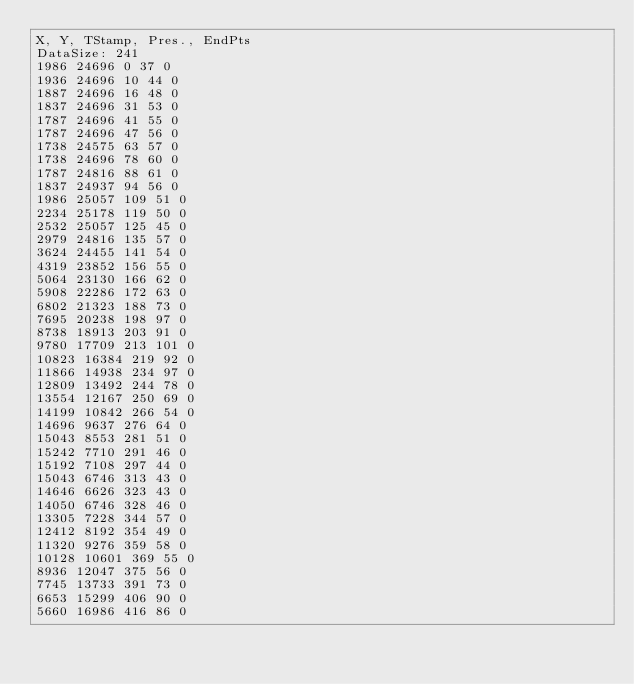Convert code to text. <code><loc_0><loc_0><loc_500><loc_500><_SML_>X, Y, TStamp, Pres., EndPts
DataSize: 241
1986 24696 0 37 0
1936 24696 10 44 0
1887 24696 16 48 0
1837 24696 31 53 0
1787 24696 41 55 0
1787 24696 47 56 0
1738 24575 63 57 0
1738 24696 78 60 0
1787 24816 88 61 0
1837 24937 94 56 0
1986 25057 109 51 0
2234 25178 119 50 0
2532 25057 125 45 0
2979 24816 135 57 0
3624 24455 141 54 0
4319 23852 156 55 0
5064 23130 166 62 0
5908 22286 172 63 0
6802 21323 188 73 0
7695 20238 198 97 0
8738 18913 203 91 0
9780 17709 213 101 0
10823 16384 219 92 0
11866 14938 234 97 0
12809 13492 244 78 0
13554 12167 250 69 0
14199 10842 266 54 0
14696 9637 276 64 0
15043 8553 281 51 0
15242 7710 291 46 0
15192 7108 297 44 0
15043 6746 313 43 0
14646 6626 323 43 0
14050 6746 328 46 0
13305 7228 344 57 0
12412 8192 354 49 0
11320 9276 359 58 0
10128 10601 369 55 0
8936 12047 375 56 0
7745 13733 391 73 0
6653 15299 406 90 0
5660 16986 416 86 0</code> 